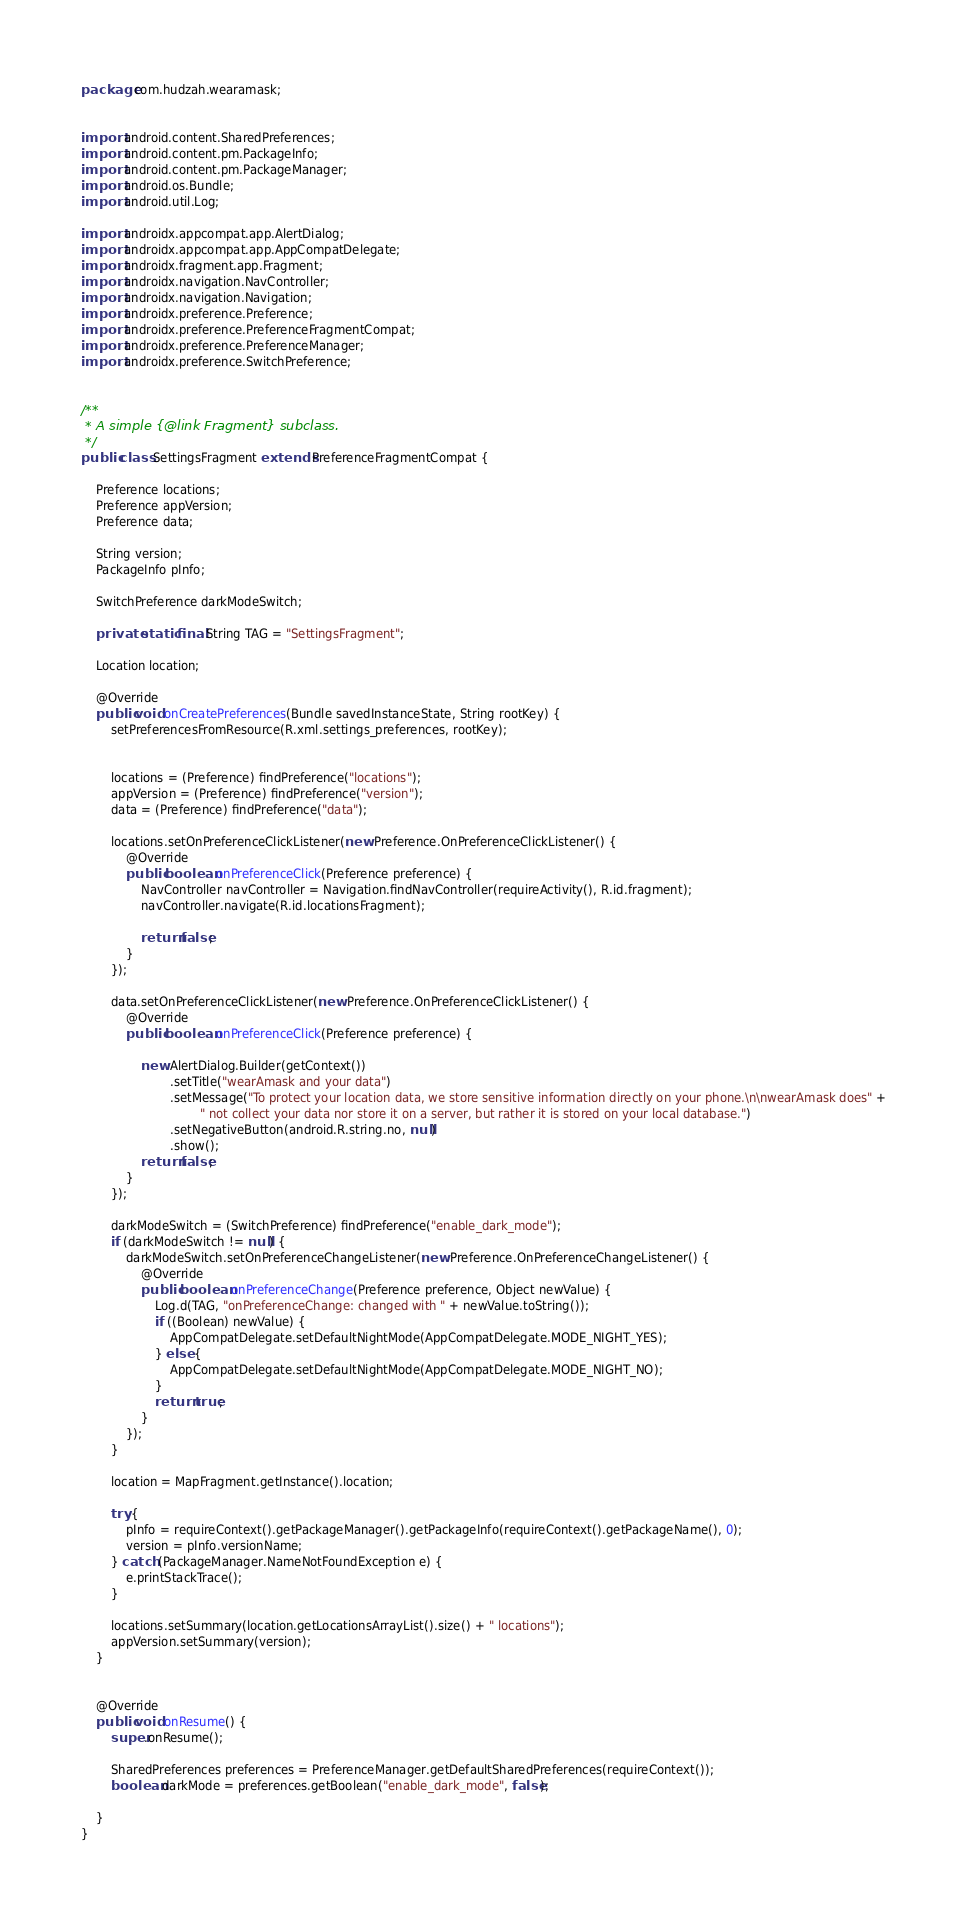Convert code to text. <code><loc_0><loc_0><loc_500><loc_500><_Java_>package com.hudzah.wearamask;


import android.content.SharedPreferences;
import android.content.pm.PackageInfo;
import android.content.pm.PackageManager;
import android.os.Bundle;
import android.util.Log;

import androidx.appcompat.app.AlertDialog;
import androidx.appcompat.app.AppCompatDelegate;
import androidx.fragment.app.Fragment;
import androidx.navigation.NavController;
import androidx.navigation.Navigation;
import androidx.preference.Preference;
import androidx.preference.PreferenceFragmentCompat;
import androidx.preference.PreferenceManager;
import androidx.preference.SwitchPreference;


/**
 * A simple {@link Fragment} subclass.
 */
public class SettingsFragment extends PreferenceFragmentCompat {

    Preference locations;
    Preference appVersion;
    Preference data;

    String version;
    PackageInfo pInfo;

    SwitchPreference darkModeSwitch;

    private static final String TAG = "SettingsFragment";

    Location location;

    @Override
    public void onCreatePreferences(Bundle savedInstanceState, String rootKey) {
        setPreferencesFromResource(R.xml.settings_preferences, rootKey);


        locations = (Preference) findPreference("locations");
        appVersion = (Preference) findPreference("version");
        data = (Preference) findPreference("data");

        locations.setOnPreferenceClickListener(new Preference.OnPreferenceClickListener() {
            @Override
            public boolean onPreferenceClick(Preference preference) {
                NavController navController = Navigation.findNavController(requireActivity(), R.id.fragment);
                navController.navigate(R.id.locationsFragment);

                return false;
            }
        });

        data.setOnPreferenceClickListener(new Preference.OnPreferenceClickListener() {
            @Override
            public boolean onPreferenceClick(Preference preference) {

                new AlertDialog.Builder(getContext())
                        .setTitle("wearAmask and your data")
                        .setMessage("To protect your location data, we store sensitive information directly on your phone.\n\nwearAmask does" +
                                " not collect your data nor store it on a server, but rather it is stored on your local database.")
                        .setNegativeButton(android.R.string.no, null)
                        .show();
                return false;
            }
        });

        darkModeSwitch = (SwitchPreference) findPreference("enable_dark_mode");
        if (darkModeSwitch != null) {
            darkModeSwitch.setOnPreferenceChangeListener(new Preference.OnPreferenceChangeListener() {
                @Override
                public boolean onPreferenceChange(Preference preference, Object newValue) {
                    Log.d(TAG, "onPreferenceChange: changed with " + newValue.toString());
                    if ((Boolean) newValue) {
                        AppCompatDelegate.setDefaultNightMode(AppCompatDelegate.MODE_NIGHT_YES);
                    } else {
                        AppCompatDelegate.setDefaultNightMode(AppCompatDelegate.MODE_NIGHT_NO);
                    }
                    return true;
                }
            });
        }

        location = MapFragment.getInstance().location;

        try {
            pInfo = requireContext().getPackageManager().getPackageInfo(requireContext().getPackageName(), 0);
            version = pInfo.versionName;
        } catch (PackageManager.NameNotFoundException e) {
            e.printStackTrace();
        }

        locations.setSummary(location.getLocationsArrayList().size() + " locations");
        appVersion.setSummary(version);
    }


    @Override
    public void onResume() {
        super.onResume();

        SharedPreferences preferences = PreferenceManager.getDefaultSharedPreferences(requireContext());
        boolean darkMode = preferences.getBoolean("enable_dark_mode", false);

    }
}
</code> 